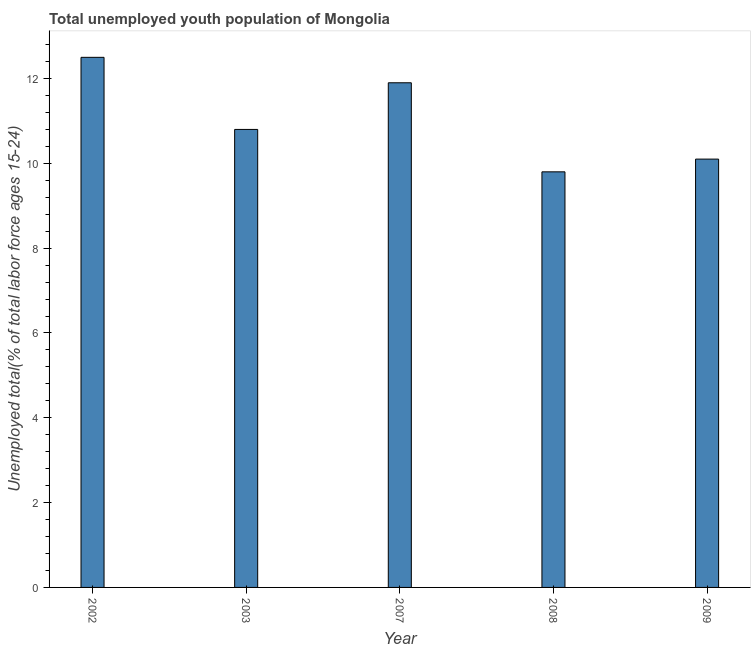Does the graph contain any zero values?
Provide a short and direct response. No. What is the title of the graph?
Offer a very short reply. Total unemployed youth population of Mongolia. What is the label or title of the X-axis?
Give a very brief answer. Year. What is the label or title of the Y-axis?
Your response must be concise. Unemployed total(% of total labor force ages 15-24). What is the unemployed youth in 2003?
Offer a terse response. 10.8. Across all years, what is the minimum unemployed youth?
Provide a short and direct response. 9.8. In which year was the unemployed youth maximum?
Ensure brevity in your answer.  2002. What is the sum of the unemployed youth?
Keep it short and to the point. 55.1. What is the average unemployed youth per year?
Ensure brevity in your answer.  11.02. What is the median unemployed youth?
Provide a succinct answer. 10.8. In how many years, is the unemployed youth greater than 4 %?
Your answer should be very brief. 5. Do a majority of the years between 2002 and 2007 (inclusive) have unemployed youth greater than 3.6 %?
Your response must be concise. Yes. What is the ratio of the unemployed youth in 2002 to that in 2008?
Ensure brevity in your answer.  1.28. Is the difference between the unemployed youth in 2007 and 2009 greater than the difference between any two years?
Offer a terse response. No. What is the difference between the highest and the lowest unemployed youth?
Offer a terse response. 2.7. What is the difference between two consecutive major ticks on the Y-axis?
Your answer should be very brief. 2. What is the Unemployed total(% of total labor force ages 15-24) in 2003?
Provide a short and direct response. 10.8. What is the Unemployed total(% of total labor force ages 15-24) of 2007?
Offer a very short reply. 11.9. What is the Unemployed total(% of total labor force ages 15-24) of 2008?
Keep it short and to the point. 9.8. What is the Unemployed total(% of total labor force ages 15-24) of 2009?
Provide a short and direct response. 10.1. What is the difference between the Unemployed total(% of total labor force ages 15-24) in 2002 and 2007?
Make the answer very short. 0.6. What is the difference between the Unemployed total(% of total labor force ages 15-24) in 2002 and 2008?
Provide a succinct answer. 2.7. What is the difference between the Unemployed total(% of total labor force ages 15-24) in 2003 and 2007?
Your answer should be very brief. -1.1. What is the difference between the Unemployed total(% of total labor force ages 15-24) in 2003 and 2009?
Provide a short and direct response. 0.7. What is the difference between the Unemployed total(% of total labor force ages 15-24) in 2007 and 2009?
Your answer should be compact. 1.8. What is the difference between the Unemployed total(% of total labor force ages 15-24) in 2008 and 2009?
Make the answer very short. -0.3. What is the ratio of the Unemployed total(% of total labor force ages 15-24) in 2002 to that in 2003?
Ensure brevity in your answer.  1.16. What is the ratio of the Unemployed total(% of total labor force ages 15-24) in 2002 to that in 2007?
Provide a short and direct response. 1.05. What is the ratio of the Unemployed total(% of total labor force ages 15-24) in 2002 to that in 2008?
Provide a short and direct response. 1.28. What is the ratio of the Unemployed total(% of total labor force ages 15-24) in 2002 to that in 2009?
Ensure brevity in your answer.  1.24. What is the ratio of the Unemployed total(% of total labor force ages 15-24) in 2003 to that in 2007?
Provide a short and direct response. 0.91. What is the ratio of the Unemployed total(% of total labor force ages 15-24) in 2003 to that in 2008?
Provide a short and direct response. 1.1. What is the ratio of the Unemployed total(% of total labor force ages 15-24) in 2003 to that in 2009?
Give a very brief answer. 1.07. What is the ratio of the Unemployed total(% of total labor force ages 15-24) in 2007 to that in 2008?
Give a very brief answer. 1.21. What is the ratio of the Unemployed total(% of total labor force ages 15-24) in 2007 to that in 2009?
Give a very brief answer. 1.18. 